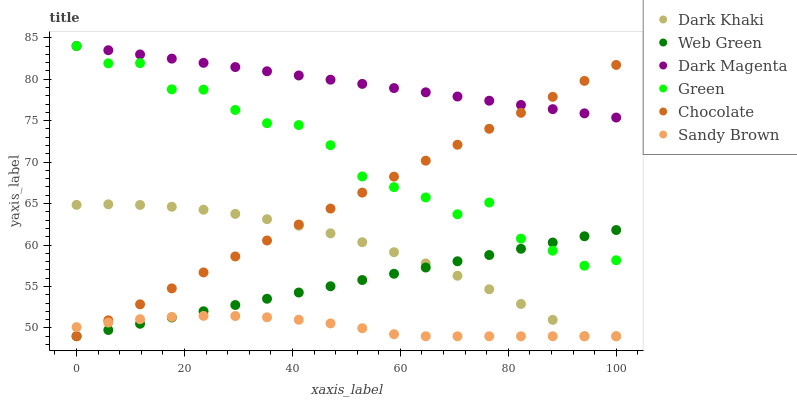Does Sandy Brown have the minimum area under the curve?
Answer yes or no. Yes. Does Dark Magenta have the maximum area under the curve?
Answer yes or no. Yes. Does Web Green have the minimum area under the curve?
Answer yes or no. No. Does Web Green have the maximum area under the curve?
Answer yes or no. No. Is Web Green the smoothest?
Answer yes or no. Yes. Is Green the roughest?
Answer yes or no. Yes. Is Chocolate the smoothest?
Answer yes or no. No. Is Chocolate the roughest?
Answer yes or no. No. Does Web Green have the lowest value?
Answer yes or no. Yes. Does Green have the lowest value?
Answer yes or no. No. Does Green have the highest value?
Answer yes or no. Yes. Does Web Green have the highest value?
Answer yes or no. No. Is Sandy Brown less than Green?
Answer yes or no. Yes. Is Green greater than Sandy Brown?
Answer yes or no. Yes. Does Web Green intersect Dark Khaki?
Answer yes or no. Yes. Is Web Green less than Dark Khaki?
Answer yes or no. No. Is Web Green greater than Dark Khaki?
Answer yes or no. No. Does Sandy Brown intersect Green?
Answer yes or no. No. 